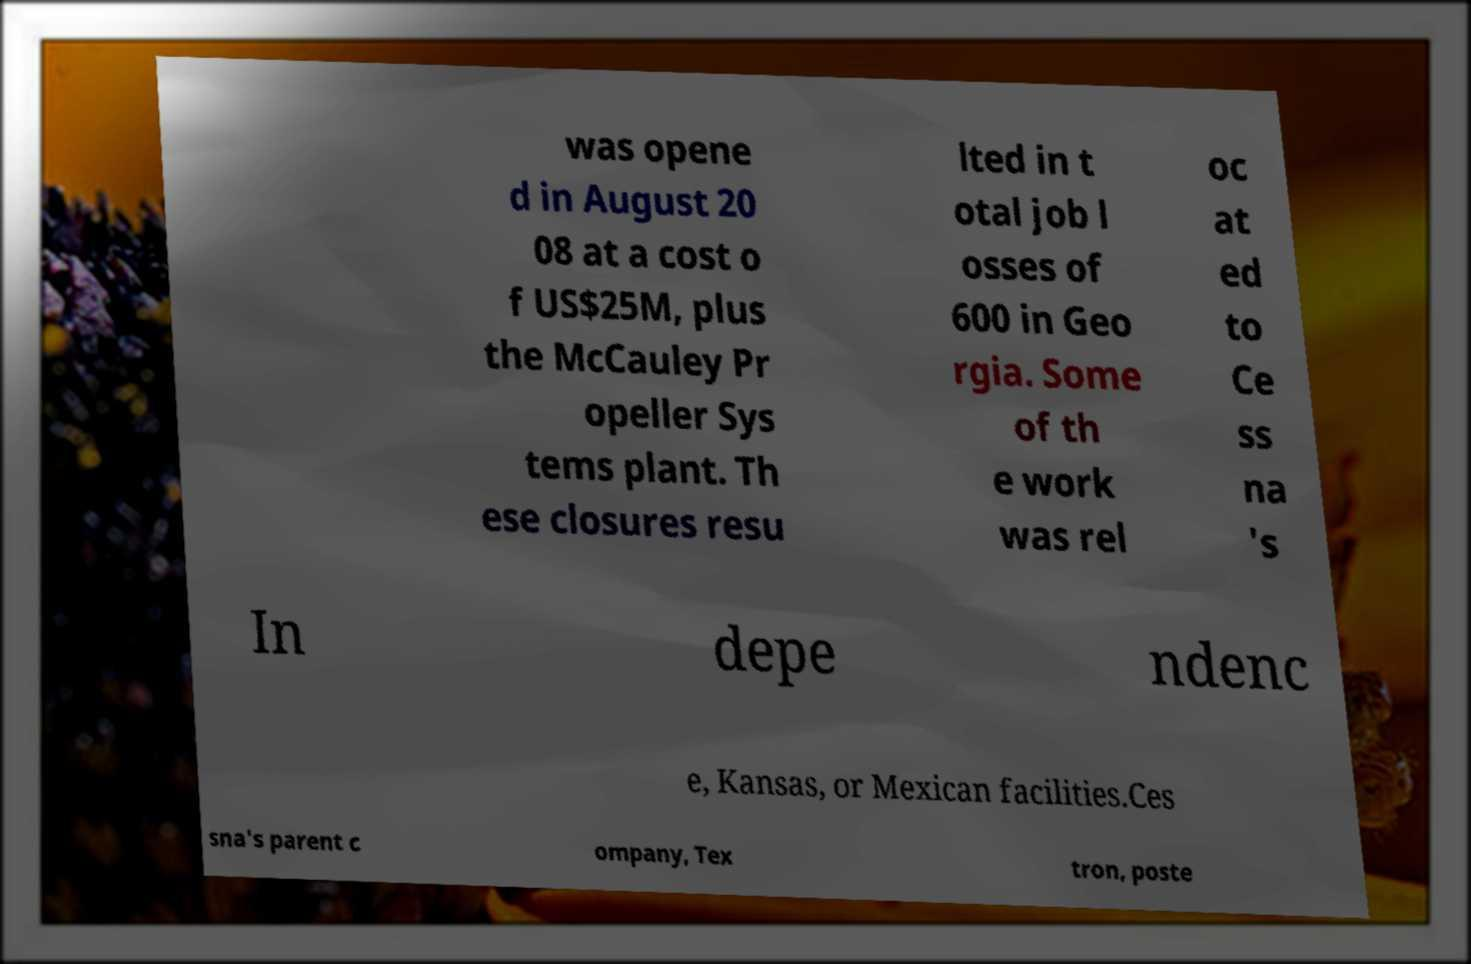Could you extract and type out the text from this image? was opene d in August 20 08 at a cost o f US$25M, plus the McCauley Pr opeller Sys tems plant. Th ese closures resu lted in t otal job l osses of 600 in Geo rgia. Some of th e work was rel oc at ed to Ce ss na 's In depe ndenc e, Kansas, or Mexican facilities.Ces sna's parent c ompany, Tex tron, poste 